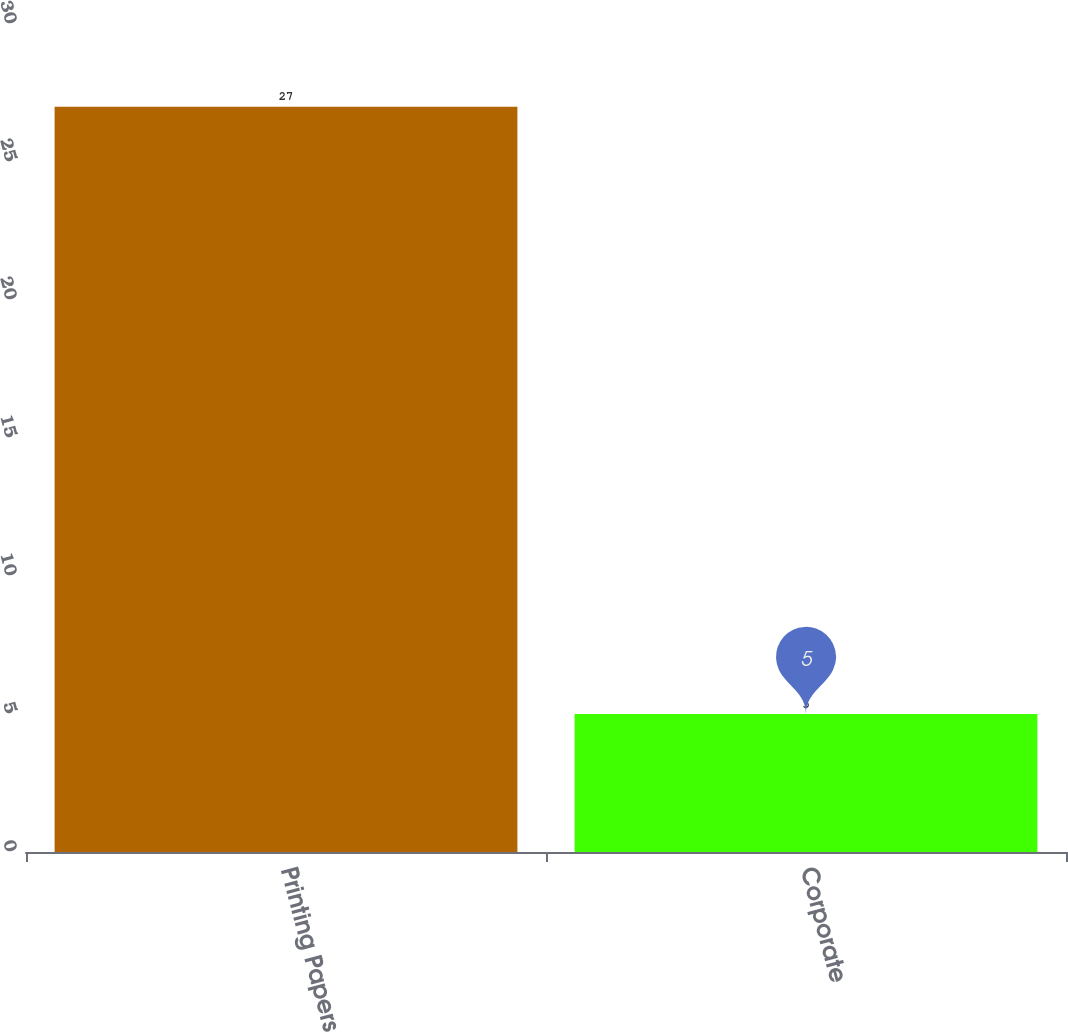Convert chart to OTSL. <chart><loc_0><loc_0><loc_500><loc_500><bar_chart><fcel>Printing Papers<fcel>Corporate<nl><fcel>27<fcel>5<nl></chart> 